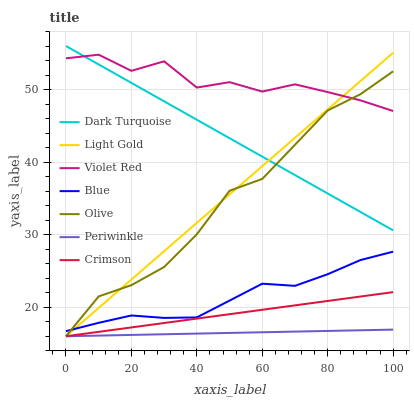Does Periwinkle have the minimum area under the curve?
Answer yes or no. Yes. Does Violet Red have the maximum area under the curve?
Answer yes or no. Yes. Does Dark Turquoise have the minimum area under the curve?
Answer yes or no. No. Does Dark Turquoise have the maximum area under the curve?
Answer yes or no. No. Is Crimson the smoothest?
Answer yes or no. Yes. Is Violet Red the roughest?
Answer yes or no. Yes. Is Dark Turquoise the smoothest?
Answer yes or no. No. Is Dark Turquoise the roughest?
Answer yes or no. No. Does Crimson have the lowest value?
Answer yes or no. Yes. Does Dark Turquoise have the lowest value?
Answer yes or no. No. Does Dark Turquoise have the highest value?
Answer yes or no. Yes. Does Violet Red have the highest value?
Answer yes or no. No. Is Periwinkle less than Violet Red?
Answer yes or no. Yes. Is Dark Turquoise greater than Crimson?
Answer yes or no. Yes. Does Violet Red intersect Light Gold?
Answer yes or no. Yes. Is Violet Red less than Light Gold?
Answer yes or no. No. Is Violet Red greater than Light Gold?
Answer yes or no. No. Does Periwinkle intersect Violet Red?
Answer yes or no. No. 